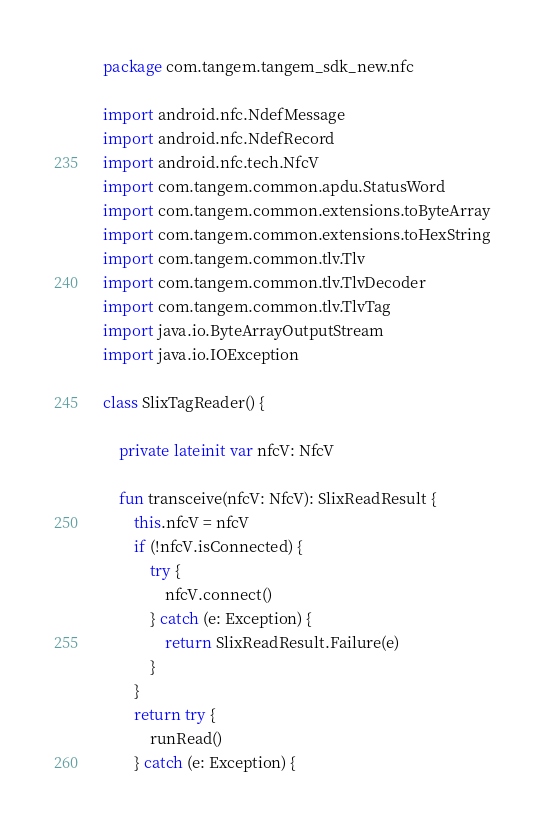<code> <loc_0><loc_0><loc_500><loc_500><_Kotlin_>package com.tangem.tangem_sdk_new.nfc

import android.nfc.NdefMessage
import android.nfc.NdefRecord
import android.nfc.tech.NfcV
import com.tangem.common.apdu.StatusWord
import com.tangem.common.extensions.toByteArray
import com.tangem.common.extensions.toHexString
import com.tangem.common.tlv.Tlv
import com.tangem.common.tlv.TlvDecoder
import com.tangem.common.tlv.TlvTag
import java.io.ByteArrayOutputStream
import java.io.IOException

class SlixTagReader() {

    private lateinit var nfcV: NfcV

    fun transceive(nfcV: NfcV): SlixReadResult {
        this.nfcV = nfcV
        if (!nfcV.isConnected) {
            try {
                nfcV.connect()
            } catch (e: Exception) {
                return SlixReadResult.Failure(e)
            }
        }
        return try {
            runRead()
        } catch (e: Exception) {</code> 